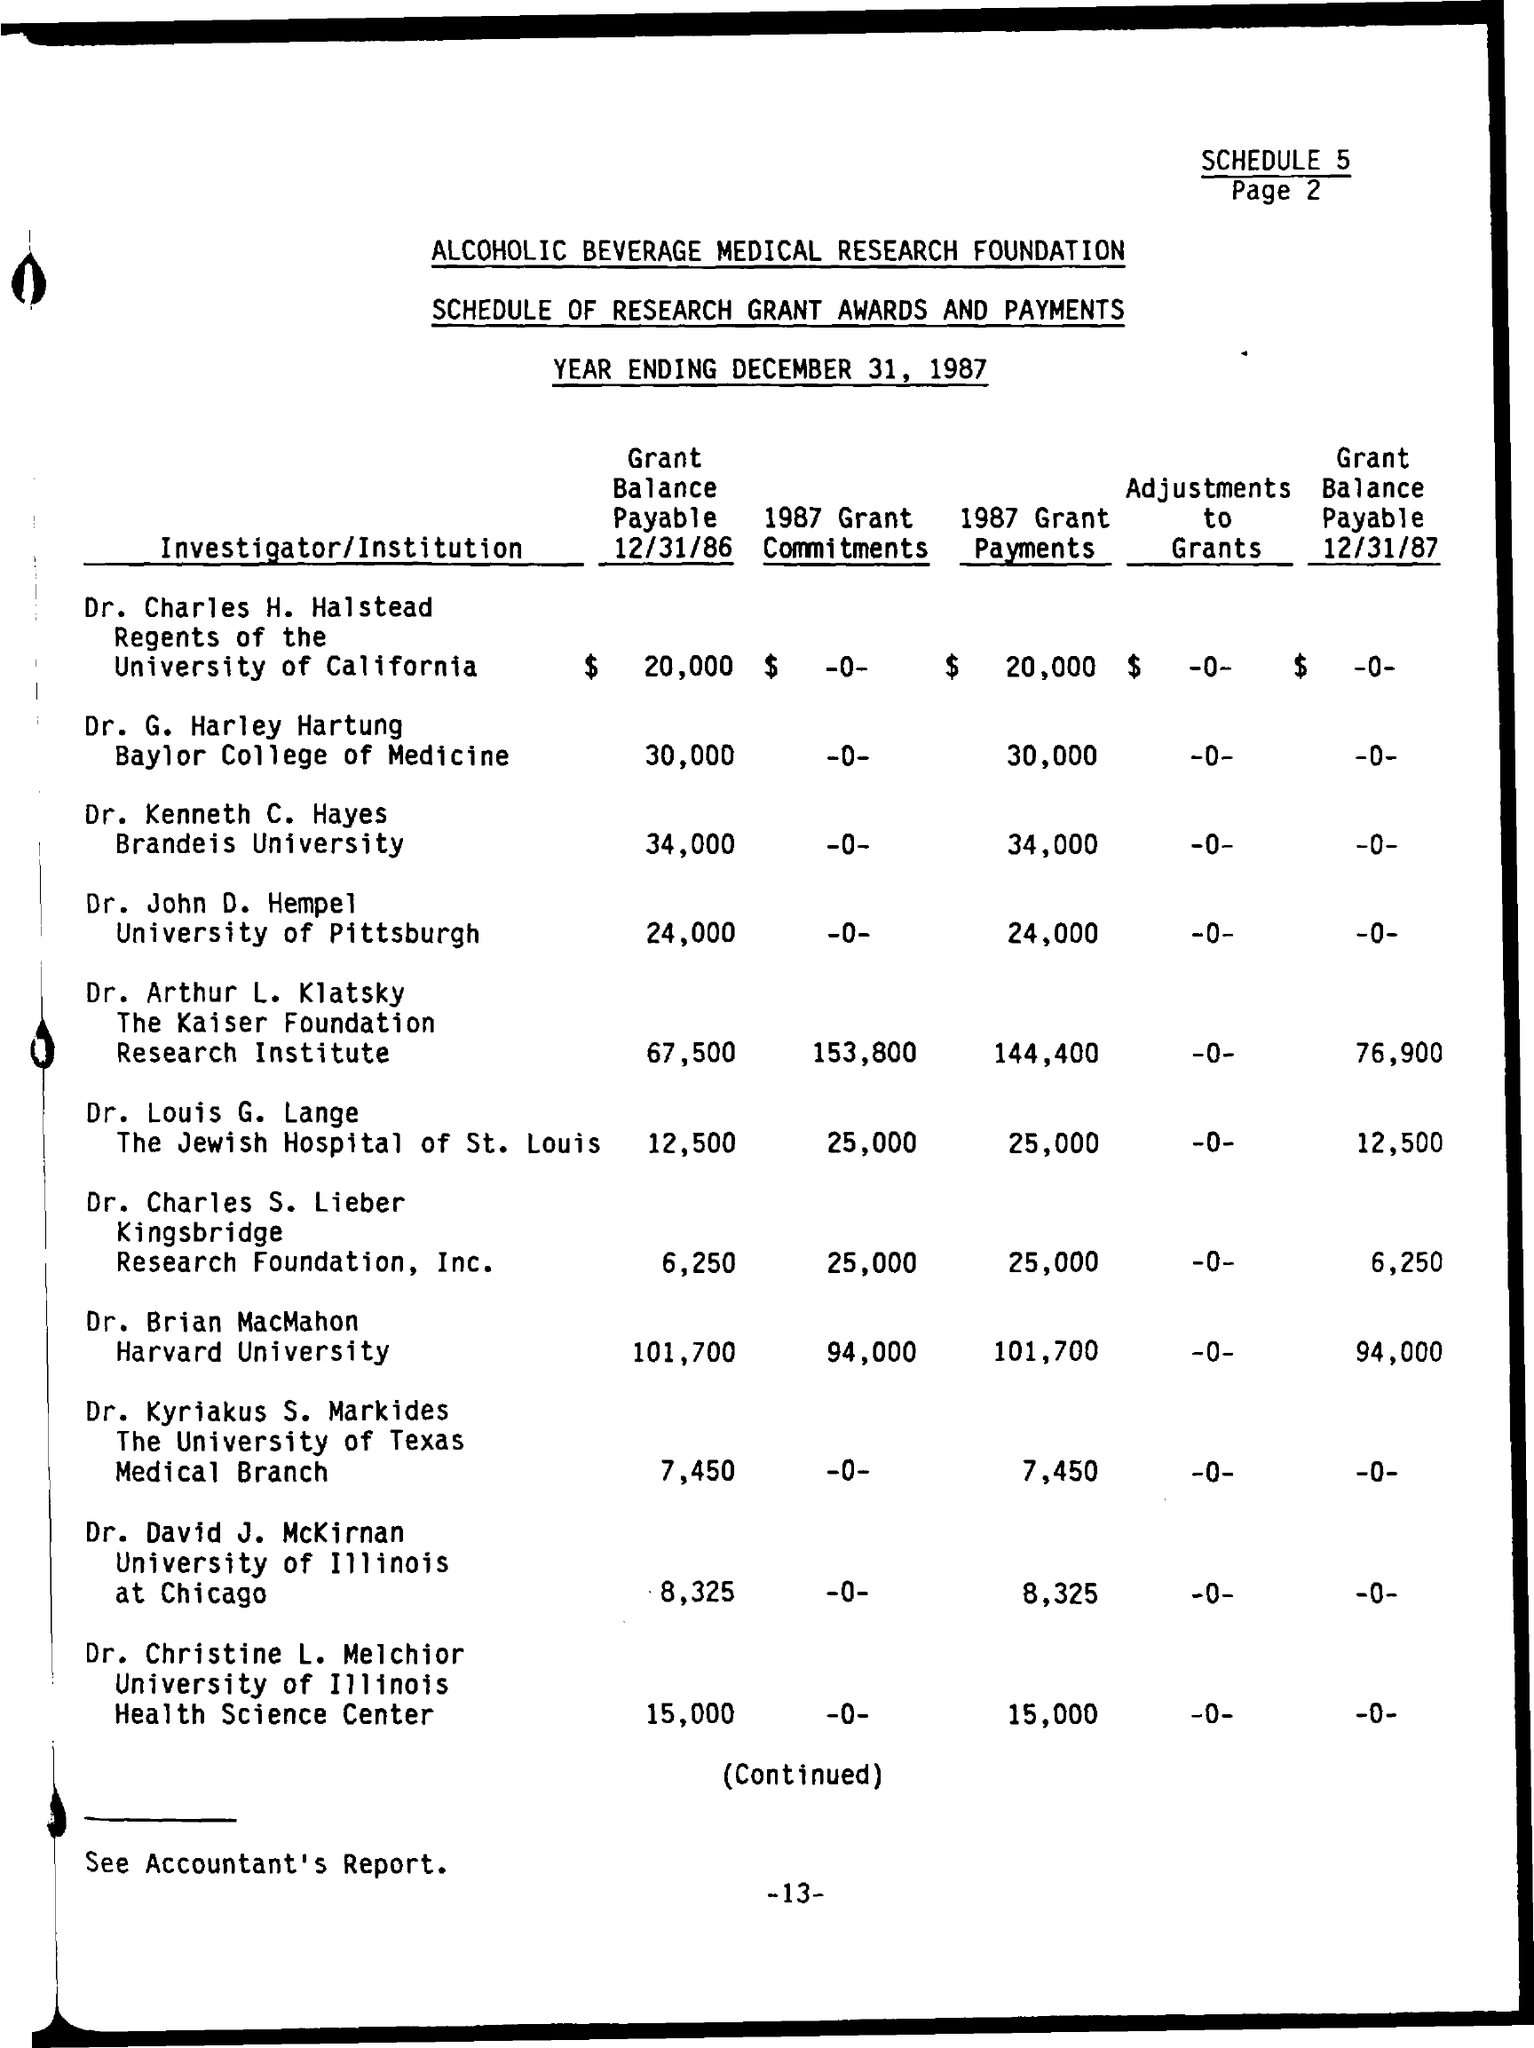When is the Year Ending ?
Offer a very short reply. DECEMBER 31, 1987. 